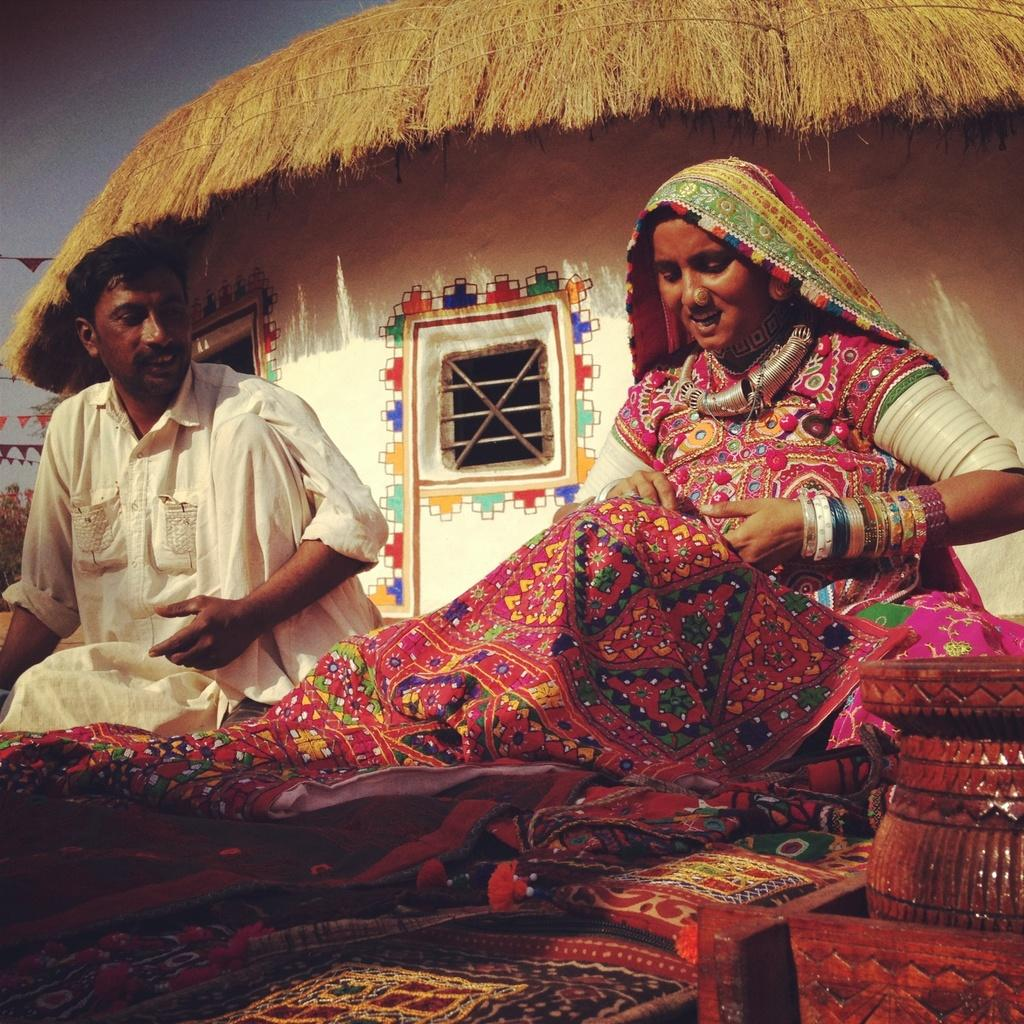How many people are present in the image? There is a man and a woman present in the image. What is the woman wearing in the image? The woman is wearing ornaments in the image. What can be seen in the background of the image? There is a hut with a window in the background of the image. What is located on the right side of the image? There is an object on the right side of the image. What type of education is the man receiving in the image? There is no indication in the image that the man is receiving any education. Does the woman have a tail in the image? There is no tail present on the woman in the image. 